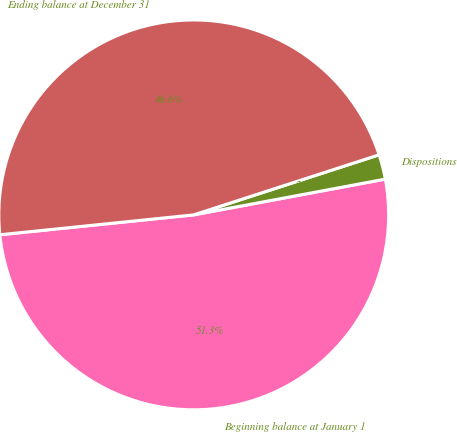Convert chart. <chart><loc_0><loc_0><loc_500><loc_500><pie_chart><fcel>Beginning balance at January 1<fcel>Dispositions<fcel>Ending balance at December 31<nl><fcel>51.31%<fcel>2.05%<fcel>46.64%<nl></chart> 